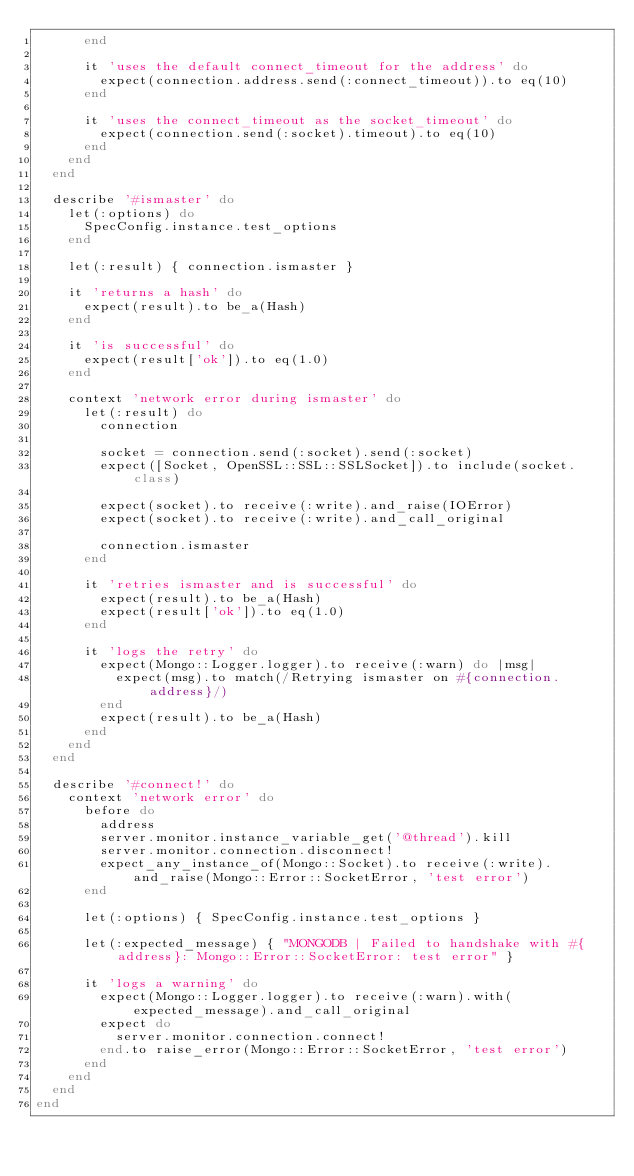Convert code to text. <code><loc_0><loc_0><loc_500><loc_500><_Ruby_>      end

      it 'uses the default connect_timeout for the address' do
        expect(connection.address.send(:connect_timeout)).to eq(10)
      end

      it 'uses the connect_timeout as the socket_timeout' do
        expect(connection.send(:socket).timeout).to eq(10)
      end
    end
  end

  describe '#ismaster' do
    let(:options) do
      SpecConfig.instance.test_options
    end

    let(:result) { connection.ismaster }

    it 'returns a hash' do
      expect(result).to be_a(Hash)
    end

    it 'is successful' do
      expect(result['ok']).to eq(1.0)
    end

    context 'network error during ismaster' do
      let(:result) do
        connection

        socket = connection.send(:socket).send(:socket)
        expect([Socket, OpenSSL::SSL::SSLSocket]).to include(socket.class)

        expect(socket).to receive(:write).and_raise(IOError)
        expect(socket).to receive(:write).and_call_original

        connection.ismaster
      end

      it 'retries ismaster and is successful' do
        expect(result).to be_a(Hash)
        expect(result['ok']).to eq(1.0)
      end

      it 'logs the retry' do
        expect(Mongo::Logger.logger).to receive(:warn) do |msg|
          expect(msg).to match(/Retrying ismaster on #{connection.address}/)
        end
        expect(result).to be_a(Hash)
      end
    end
  end

  describe '#connect!' do
    context 'network error' do
      before do
        address
        server.monitor.instance_variable_get('@thread').kill
        server.monitor.connection.disconnect!
        expect_any_instance_of(Mongo::Socket).to receive(:write).and_raise(Mongo::Error::SocketError, 'test error')
      end

      let(:options) { SpecConfig.instance.test_options }

      let(:expected_message) { "MONGODB | Failed to handshake with #{address}: Mongo::Error::SocketError: test error" }

      it 'logs a warning' do
        expect(Mongo::Logger.logger).to receive(:warn).with(expected_message).and_call_original
        expect do
          server.monitor.connection.connect!
        end.to raise_error(Mongo::Error::SocketError, 'test error')
      end
    end
  end
end
</code> 